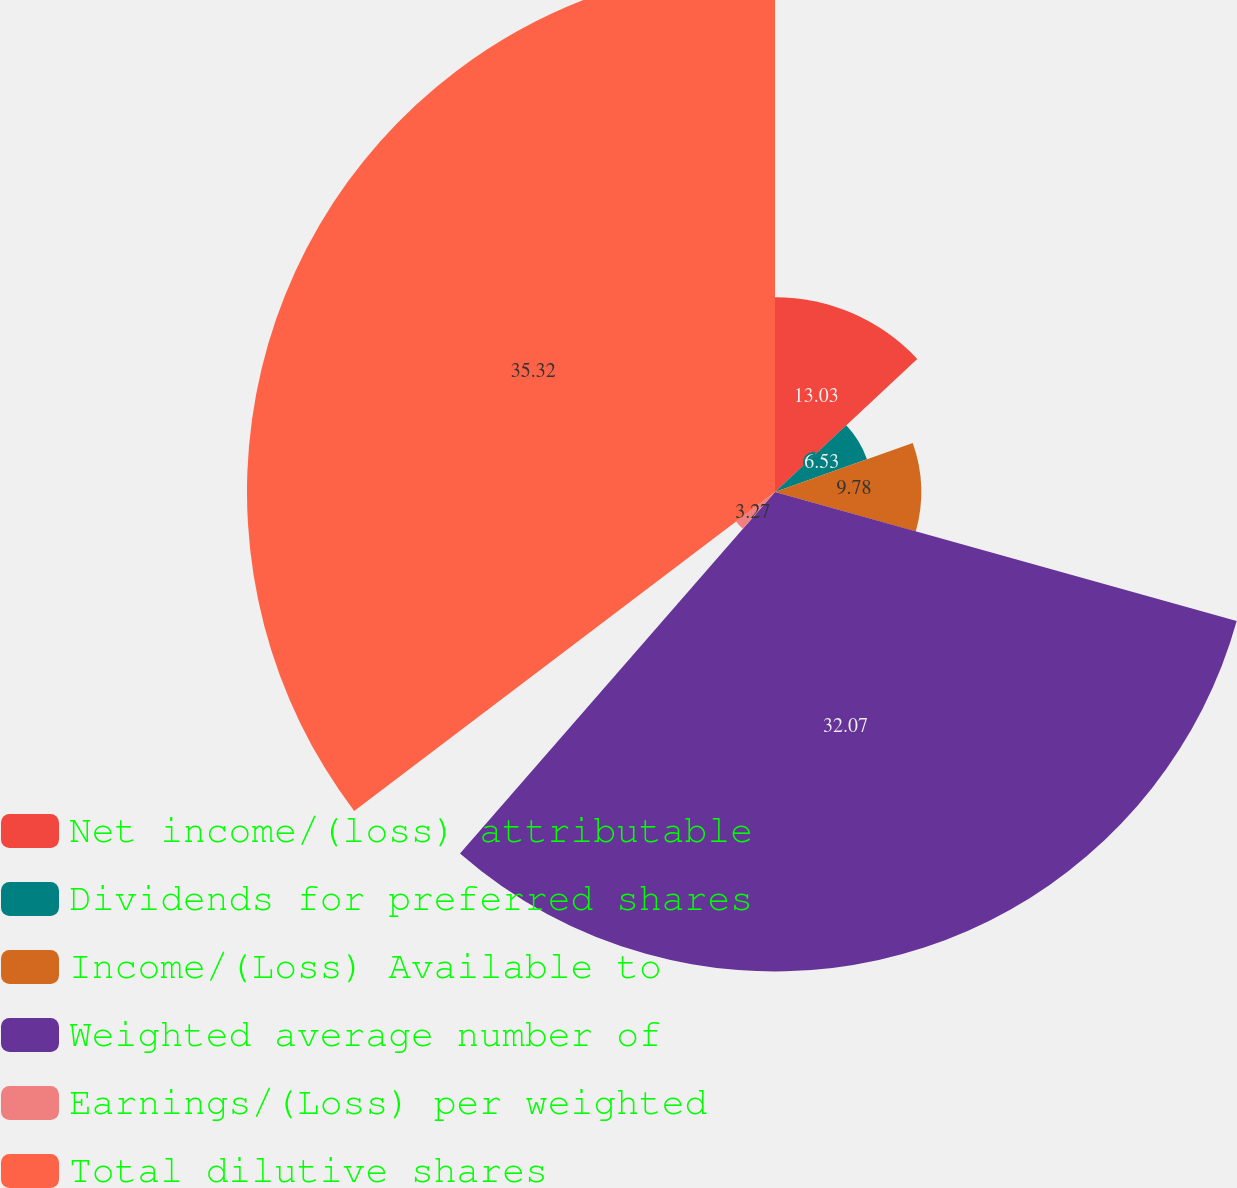Convert chart. <chart><loc_0><loc_0><loc_500><loc_500><pie_chart><fcel>Net income/(loss) attributable<fcel>Dividends for preferred shares<fcel>Income/(Loss) Available to<fcel>Weighted average number of<fcel>Earnings/(Loss) per weighted<fcel>Total dilutive shares<nl><fcel>13.03%<fcel>6.53%<fcel>9.78%<fcel>32.07%<fcel>3.27%<fcel>35.32%<nl></chart> 